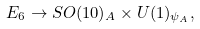Convert formula to latex. <formula><loc_0><loc_0><loc_500><loc_500>E _ { 6 } \rightarrow S O ( 1 0 ) _ { A } \times U ( 1 ) _ { \psi _ { A } } ,</formula> 